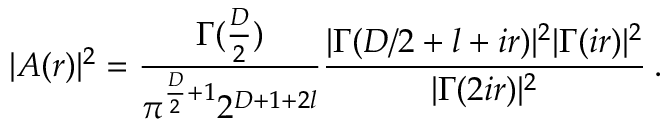Convert formula to latex. <formula><loc_0><loc_0><loc_500><loc_500>| A ( r ) | ^ { 2 } = \frac { \Gamma ( \frac { D } { 2 } ) } { \pi ^ { \frac { D } { 2 } + 1 } 2 ^ { D + 1 + 2 l } } \frac { | \Gamma ( D / 2 + l + i r ) | ^ { 2 } | \Gamma ( i r ) | ^ { 2 } } { | \Gamma ( 2 i r ) | ^ { 2 } } \, .</formula> 